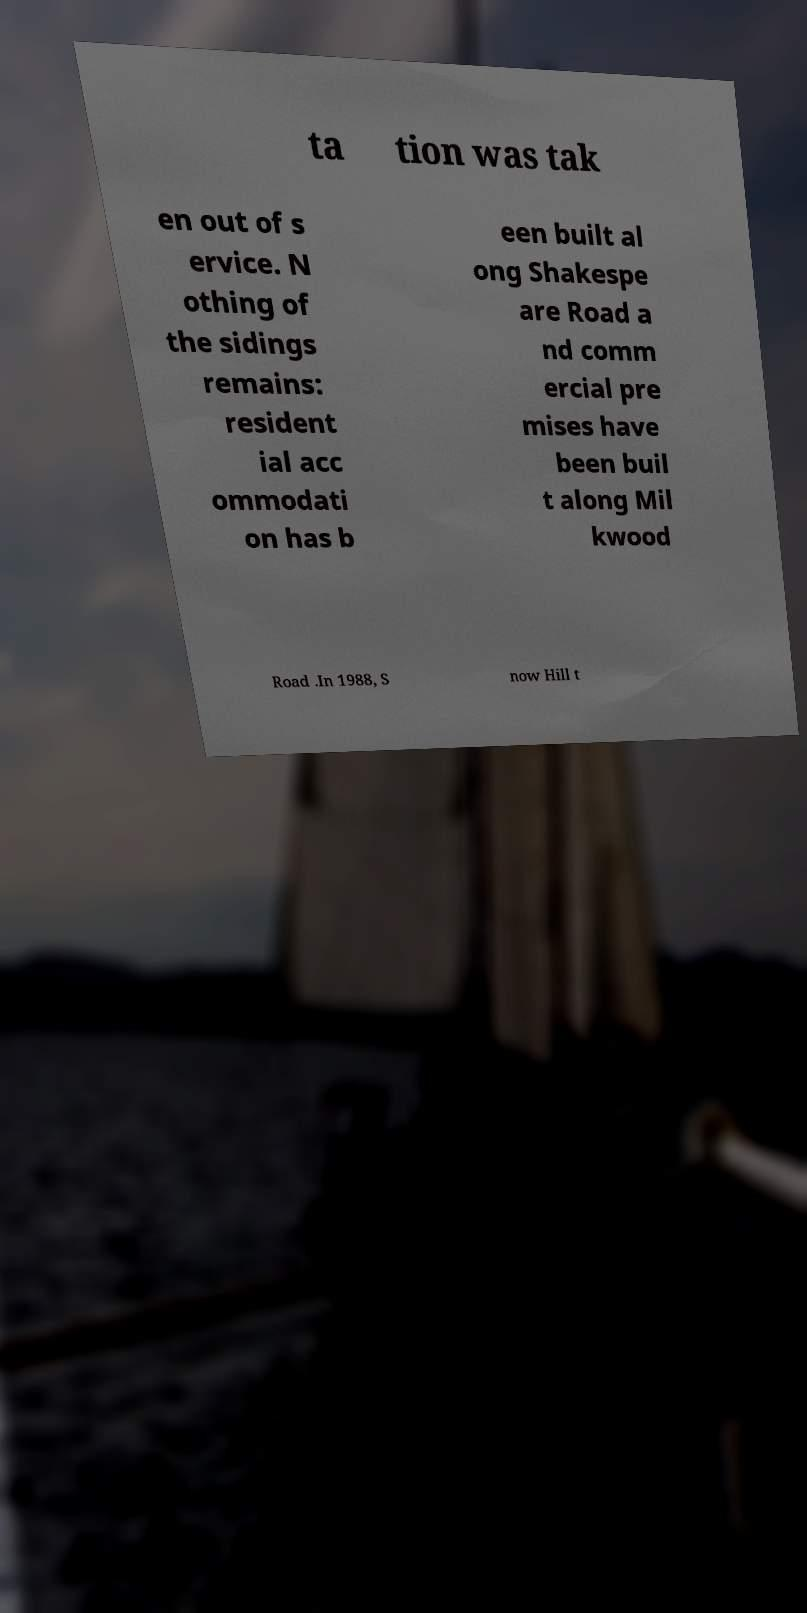What messages or text are displayed in this image? I need them in a readable, typed format. ta tion was tak en out of s ervice. N othing of the sidings remains: resident ial acc ommodati on has b een built al ong Shakespe are Road a nd comm ercial pre mises have been buil t along Mil kwood Road .In 1988, S now Hill t 